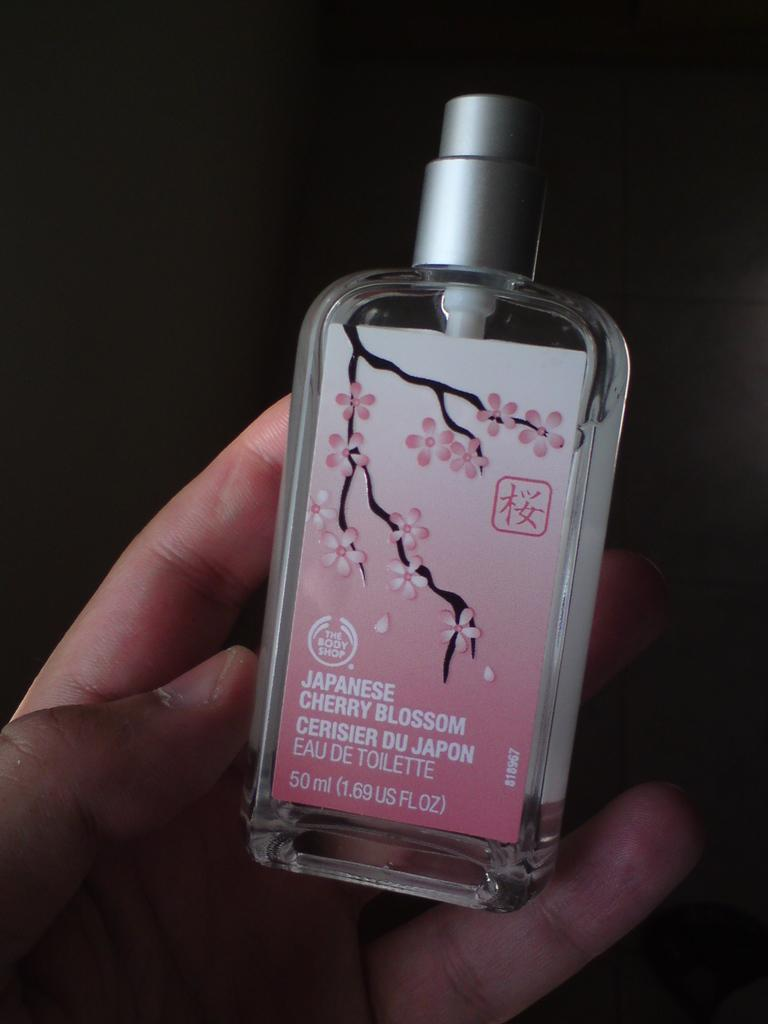Provide a one-sentence caption for the provided image. A person is holding a bottle of Japanese Cherry Blossom body perfume. 